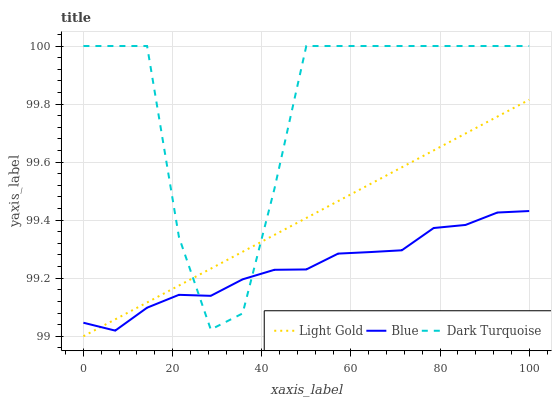Does Blue have the minimum area under the curve?
Answer yes or no. Yes. Does Dark Turquoise have the maximum area under the curve?
Answer yes or no. Yes. Does Light Gold have the minimum area under the curve?
Answer yes or no. No. Does Light Gold have the maximum area under the curve?
Answer yes or no. No. Is Light Gold the smoothest?
Answer yes or no. Yes. Is Dark Turquoise the roughest?
Answer yes or no. Yes. Is Dark Turquoise the smoothest?
Answer yes or no. No. Is Light Gold the roughest?
Answer yes or no. No. Does Light Gold have the lowest value?
Answer yes or no. Yes. Does Dark Turquoise have the lowest value?
Answer yes or no. No. Does Dark Turquoise have the highest value?
Answer yes or no. Yes. Does Light Gold have the highest value?
Answer yes or no. No. Does Blue intersect Light Gold?
Answer yes or no. Yes. Is Blue less than Light Gold?
Answer yes or no. No. Is Blue greater than Light Gold?
Answer yes or no. No. 